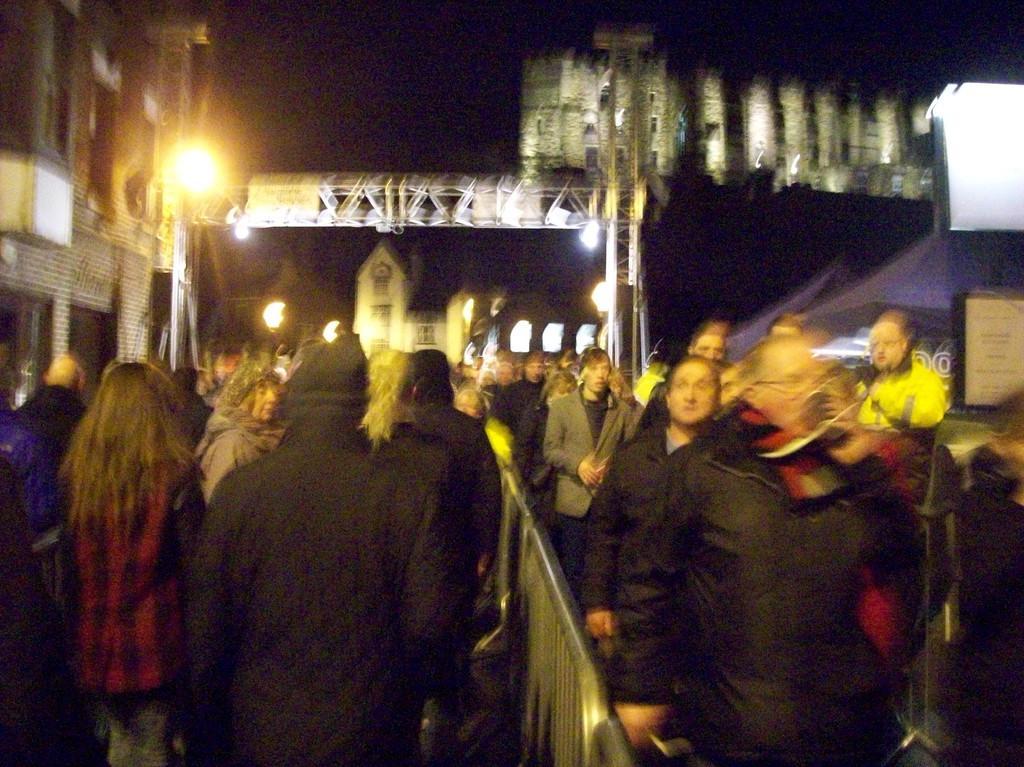Could you give a brief overview of what you see in this image? There are people and a boundary in the foreground area of the image and there are lights, poles and buildings in the background area. 